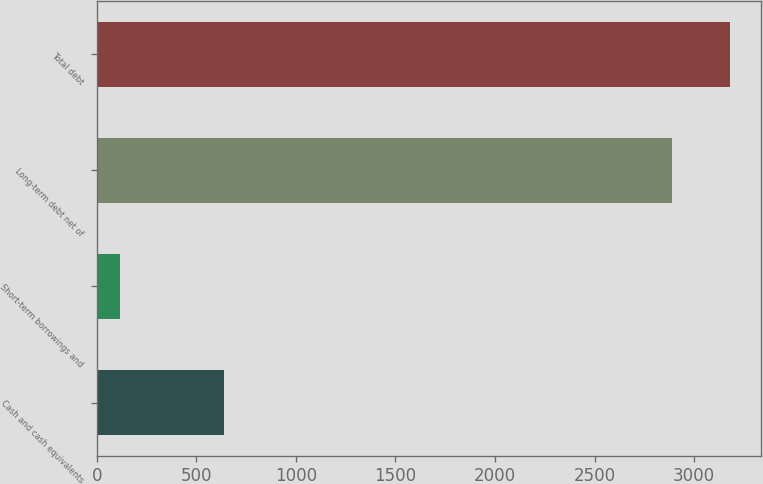Convert chart to OTSL. <chart><loc_0><loc_0><loc_500><loc_500><bar_chart><fcel>Cash and cash equivalents<fcel>Short-term borrowings and<fcel>Long-term debt net of<fcel>Total debt<nl><fcel>638<fcel>118<fcel>2890<fcel>3179<nl></chart> 